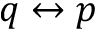<formula> <loc_0><loc_0><loc_500><loc_500>q \leftrightarrow p</formula> 